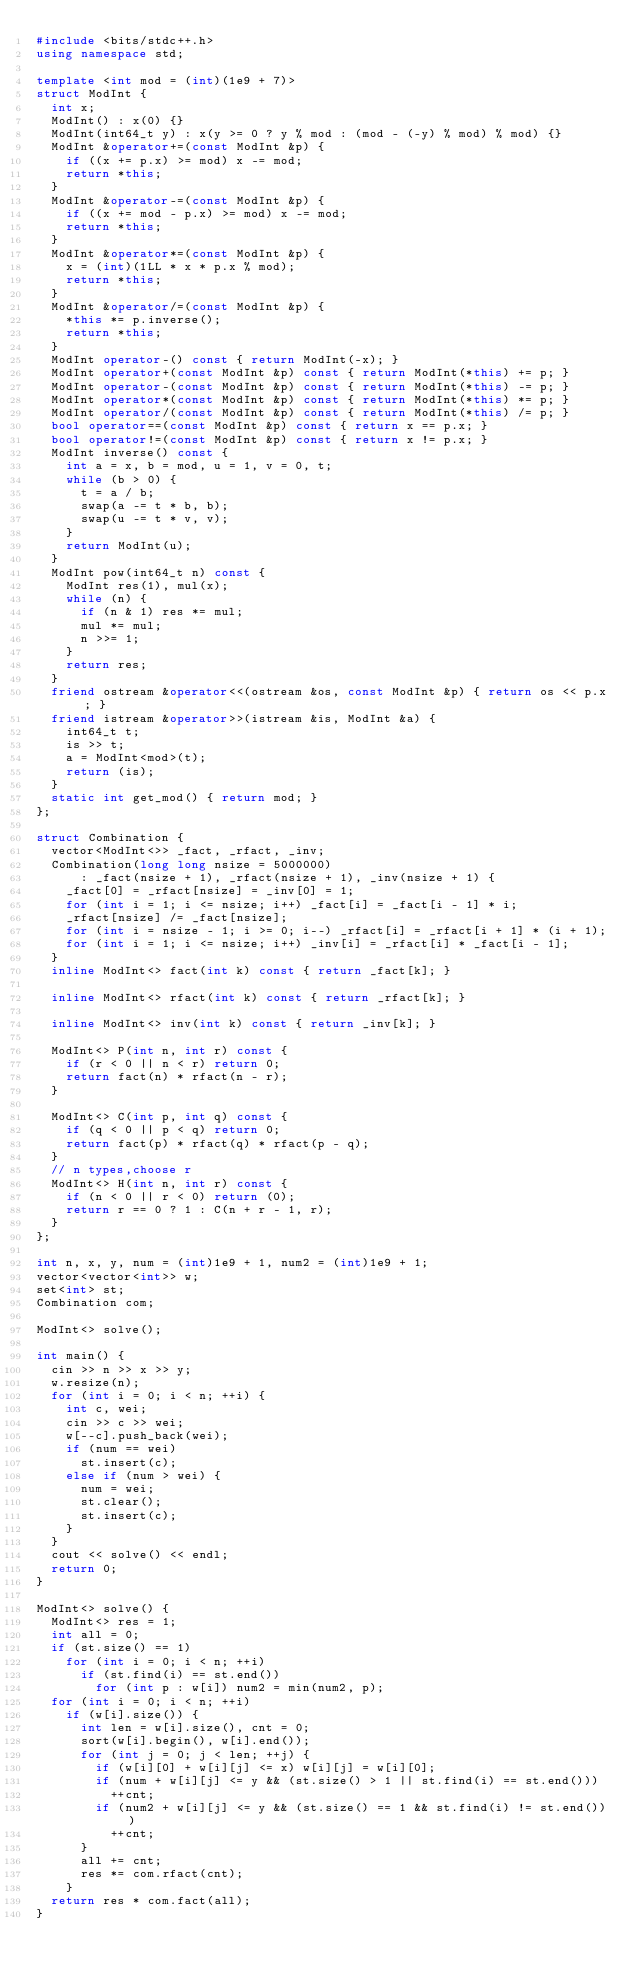Convert code to text. <code><loc_0><loc_0><loc_500><loc_500><_C++_>#include <bits/stdc++.h>
using namespace std;

template <int mod = (int)(1e9 + 7)>
struct ModInt {
  int x;
  ModInt() : x(0) {}
  ModInt(int64_t y) : x(y >= 0 ? y % mod : (mod - (-y) % mod) % mod) {}
  ModInt &operator+=(const ModInt &p) {
    if ((x += p.x) >= mod) x -= mod;
    return *this;
  }
  ModInt &operator-=(const ModInt &p) {
    if ((x += mod - p.x) >= mod) x -= mod;
    return *this;
  }
  ModInt &operator*=(const ModInt &p) {
    x = (int)(1LL * x * p.x % mod);
    return *this;
  }
  ModInt &operator/=(const ModInt &p) {
    *this *= p.inverse();
    return *this;
  }
  ModInt operator-() const { return ModInt(-x); }
  ModInt operator+(const ModInt &p) const { return ModInt(*this) += p; }
  ModInt operator-(const ModInt &p) const { return ModInt(*this) -= p; }
  ModInt operator*(const ModInt &p) const { return ModInt(*this) *= p; }
  ModInt operator/(const ModInt &p) const { return ModInt(*this) /= p; }
  bool operator==(const ModInt &p) const { return x == p.x; }
  bool operator!=(const ModInt &p) const { return x != p.x; }
  ModInt inverse() const {
    int a = x, b = mod, u = 1, v = 0, t;
    while (b > 0) {
      t = a / b;
      swap(a -= t * b, b);
      swap(u -= t * v, v);
    }
    return ModInt(u);
  }
  ModInt pow(int64_t n) const {
    ModInt res(1), mul(x);
    while (n) {
      if (n & 1) res *= mul;
      mul *= mul;
      n >>= 1;
    }
    return res;
  }
  friend ostream &operator<<(ostream &os, const ModInt &p) { return os << p.x; }
  friend istream &operator>>(istream &is, ModInt &a) {
    int64_t t;
    is >> t;
    a = ModInt<mod>(t);
    return (is);
  }
  static int get_mod() { return mod; }
};

struct Combination {
  vector<ModInt<>> _fact, _rfact, _inv;
  Combination(long long nsize = 5000000)
      : _fact(nsize + 1), _rfact(nsize + 1), _inv(nsize + 1) {
    _fact[0] = _rfact[nsize] = _inv[0] = 1;
    for (int i = 1; i <= nsize; i++) _fact[i] = _fact[i - 1] * i;
    _rfact[nsize] /= _fact[nsize];
    for (int i = nsize - 1; i >= 0; i--) _rfact[i] = _rfact[i + 1] * (i + 1);
    for (int i = 1; i <= nsize; i++) _inv[i] = _rfact[i] * _fact[i - 1];
  }
  inline ModInt<> fact(int k) const { return _fact[k]; }

  inline ModInt<> rfact(int k) const { return _rfact[k]; }

  inline ModInt<> inv(int k) const { return _inv[k]; }

  ModInt<> P(int n, int r) const {
    if (r < 0 || n < r) return 0;
    return fact(n) * rfact(n - r);
  }

  ModInt<> C(int p, int q) const {
    if (q < 0 || p < q) return 0;
    return fact(p) * rfact(q) * rfact(p - q);
  }
  // n types,choose r
  ModInt<> H(int n, int r) const {
    if (n < 0 || r < 0) return (0);
    return r == 0 ? 1 : C(n + r - 1, r);
  }
};

int n, x, y, num = (int)1e9 + 1, num2 = (int)1e9 + 1;
vector<vector<int>> w;
set<int> st;
Combination com;

ModInt<> solve();

int main() {
  cin >> n >> x >> y;
  w.resize(n);
  for (int i = 0; i < n; ++i) {
    int c, wei;
    cin >> c >> wei;
    w[--c].push_back(wei);
    if (num == wei)
      st.insert(c);
    else if (num > wei) {
      num = wei;
      st.clear();
      st.insert(c);
    }
  }
  cout << solve() << endl;
  return 0;
}

ModInt<> solve() {
  ModInt<> res = 1;
  int all = 0;
  if (st.size() == 1)
    for (int i = 0; i < n; ++i)
      if (st.find(i) == st.end())
        for (int p : w[i]) num2 = min(num2, p);
  for (int i = 0; i < n; ++i)
    if (w[i].size()) {
      int len = w[i].size(), cnt = 0;
      sort(w[i].begin(), w[i].end());
      for (int j = 0; j < len; ++j) {
        if (w[i][0] + w[i][j] <= x) w[i][j] = w[i][0];
        if (num + w[i][j] <= y && (st.size() > 1 || st.find(i) == st.end()))
          ++cnt;
        if (num2 + w[i][j] <= y && (st.size() == 1 && st.find(i) != st.end()))
          ++cnt;
      }
      all += cnt;
      res *= com.rfact(cnt);
    }
  return res * com.fact(all);
}</code> 